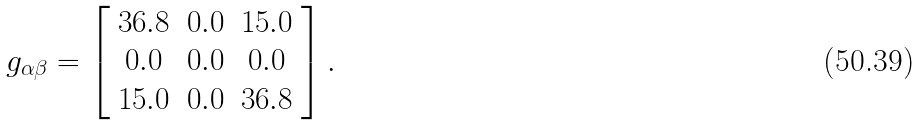Convert formula to latex. <formula><loc_0><loc_0><loc_500><loc_500>g _ { \alpha \beta } = \left [ \begin{array} { c c c } 3 6 . 8 & 0 . 0 & 1 5 . 0 \\ 0 . 0 & 0 . 0 & 0 . 0 \\ 1 5 . 0 & 0 . 0 & 3 6 . 8 \end{array} \right ] .</formula> 